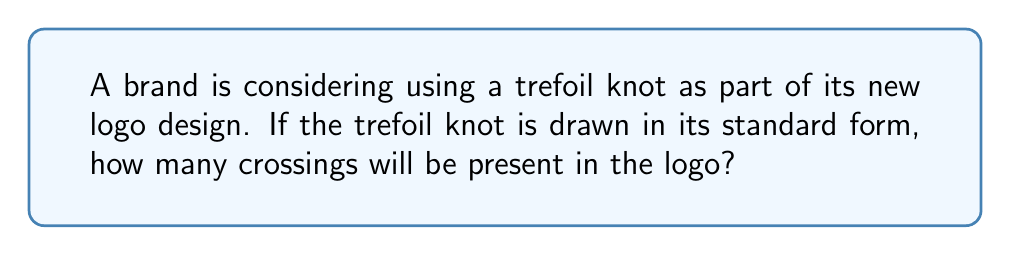Solve this math problem. To determine the number of crossings in a trefoil knot logo, we need to understand the structure of this particular knot:

1. The trefoil knot is the simplest non-trivial knot in knot theory.

2. It can be represented by the following diagram:

[asy]
import geometry;

path p = (0,0)..(1,1)..(2,0)..(1,-1)..cycle;
draw(p, linewidth(2));
draw(p, shift(1.9,0), linewidth(2));
draw(p, shift(0.1,0), linewidth(2));

dot((0.4,0.4));
dot((1,0.7));
dot((1.6,0.4));
[/asy]

3. In this standard representation, we can clearly see that the trefoil knot has exactly three crossings.

4. These crossings occur where one strand of the knot passes over or under another strand.

5. The number of crossings is an important invariant in knot theory, as it helps classify different types of knots.

6. For the trefoil knot, this crossing number is always 3 in its minimal representation, which is what we see in the standard form.

Therefore, if the brand uses a trefoil knot in its standard form for the logo, it will have 3 crossings.
Answer: 3 crossings 